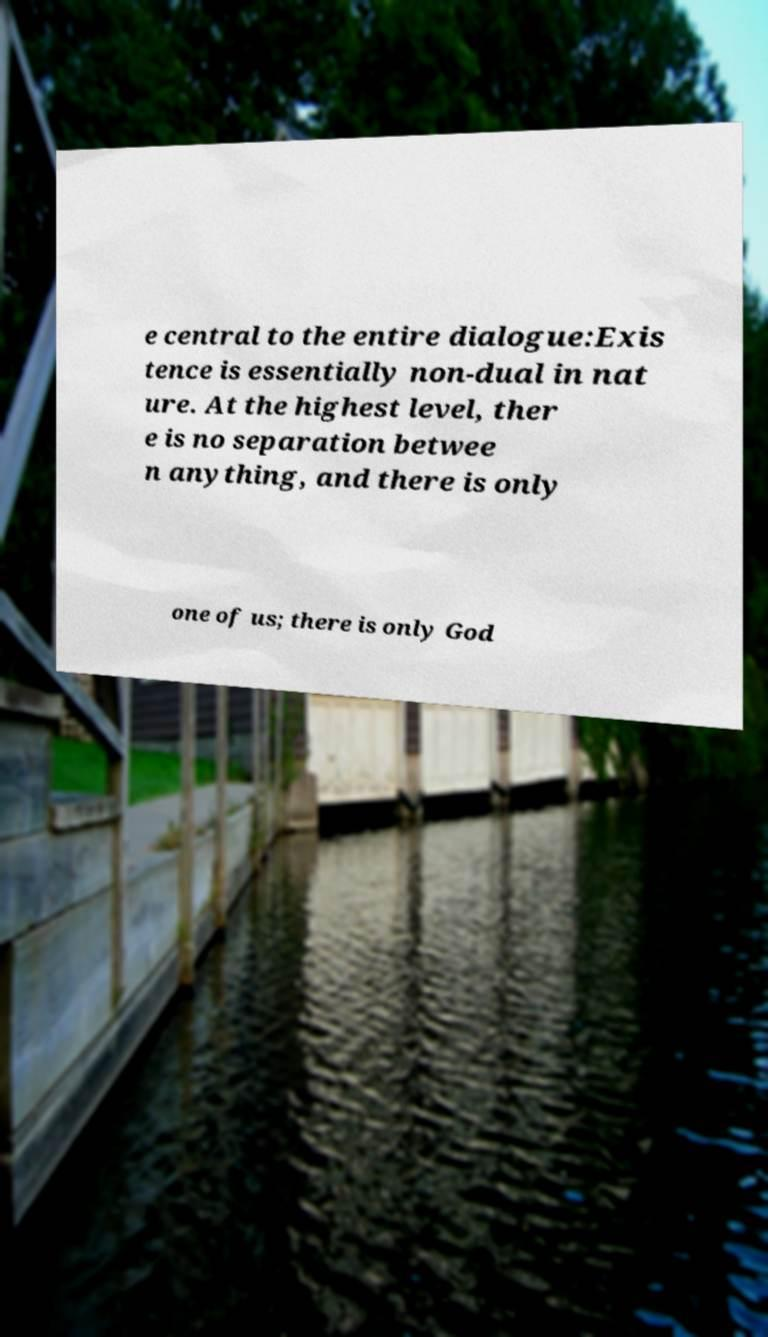I need the written content from this picture converted into text. Can you do that? e central to the entire dialogue:Exis tence is essentially non-dual in nat ure. At the highest level, ther e is no separation betwee n anything, and there is only one of us; there is only God 